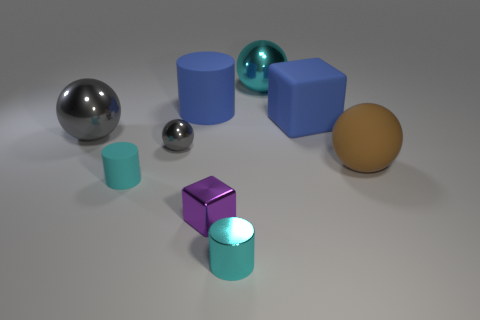Subtract all metallic balls. How many balls are left? 1 Subtract all brown blocks. How many cyan cylinders are left? 2 Subtract 2 blocks. How many blocks are left? 0 Add 1 big cyan metallic cylinders. How many objects exist? 10 Subtract all gray balls. How many balls are left? 2 Subtract 1 blue blocks. How many objects are left? 8 Subtract all cylinders. How many objects are left? 6 Subtract all brown cylinders. Subtract all red cubes. How many cylinders are left? 3 Subtract all tiny yellow metallic objects. Subtract all large blue cylinders. How many objects are left? 8 Add 1 rubber blocks. How many rubber blocks are left? 2 